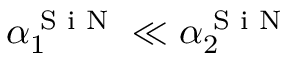Convert formula to latex. <formula><loc_0><loc_0><loc_500><loc_500>\alpha _ { 1 } ^ { S i N } \ll \alpha _ { 2 } ^ { S i N }</formula> 